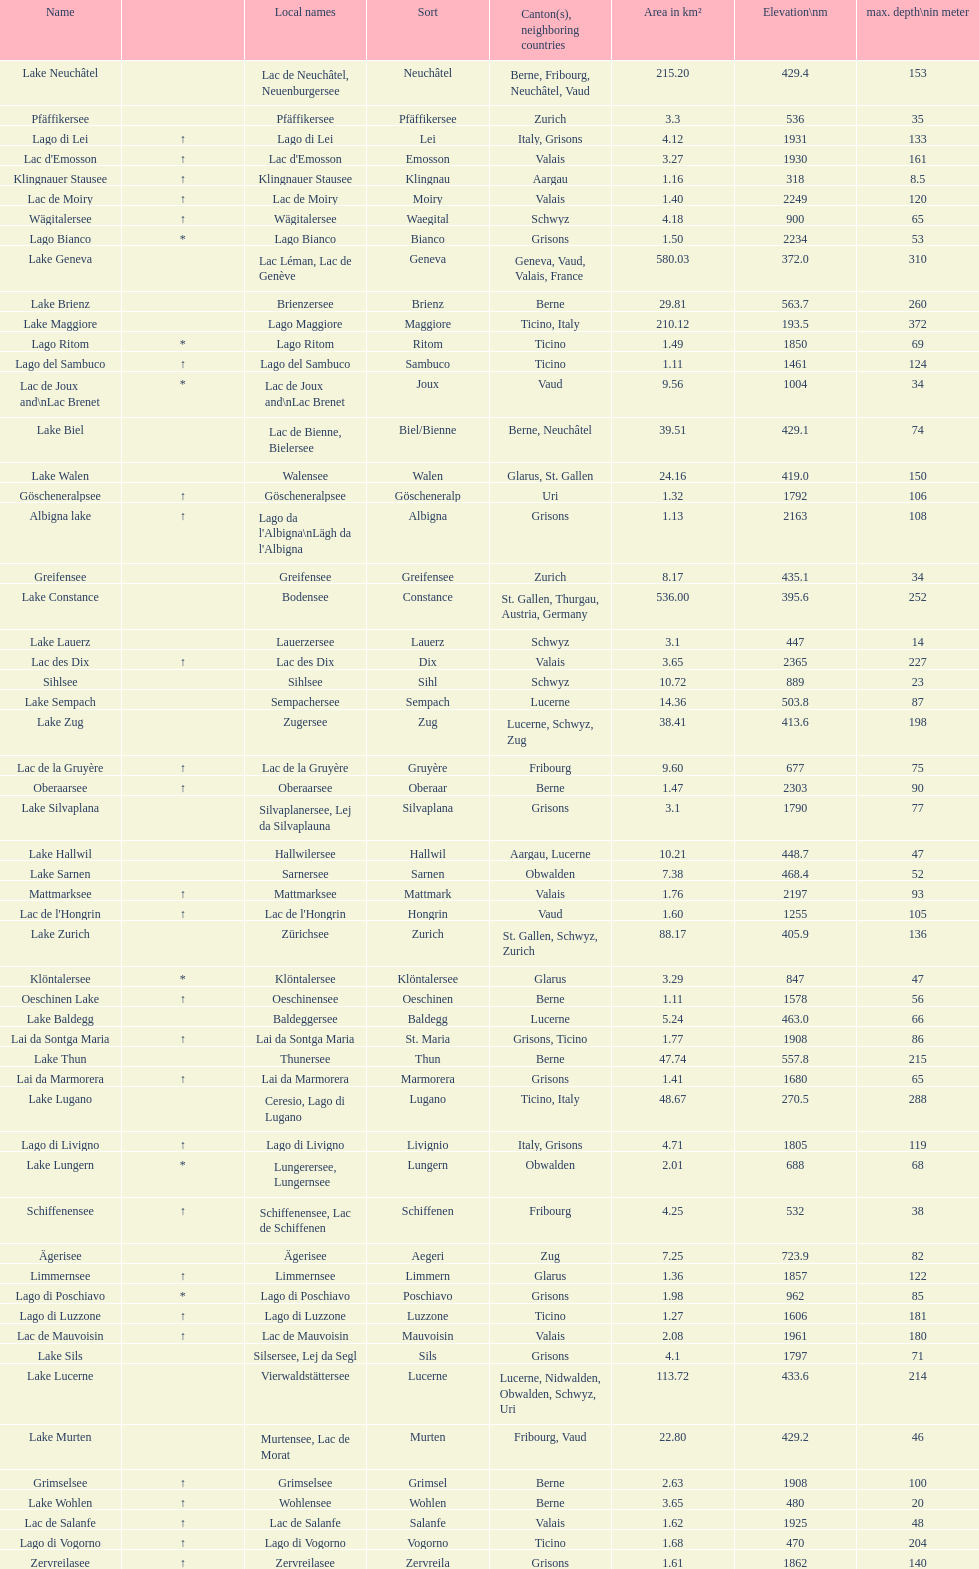What is the total area in km² of lake sils? 4.1. 